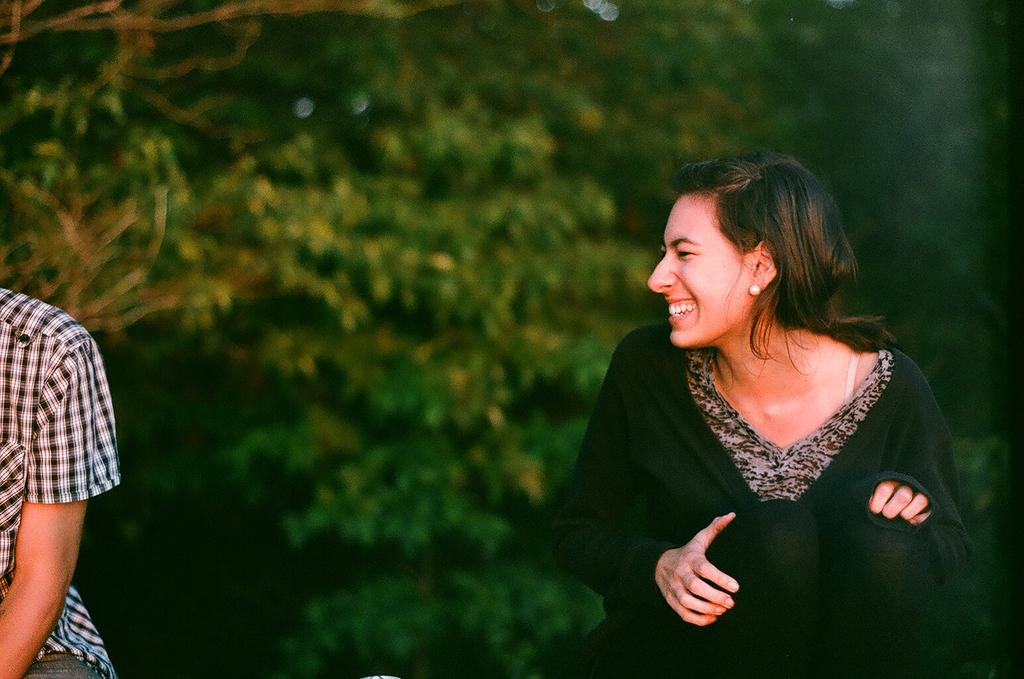What is the lady on the right side of the image doing? The lady is sitting and smiling on the right side of the image. What can be seen on the left side of the image? There is a person on the left side of the image. Can you describe the background of the image? The background of the image is green and blurred. What type of cloud is present in the image? There is no cloud present in the image; the background is green and blurred. 